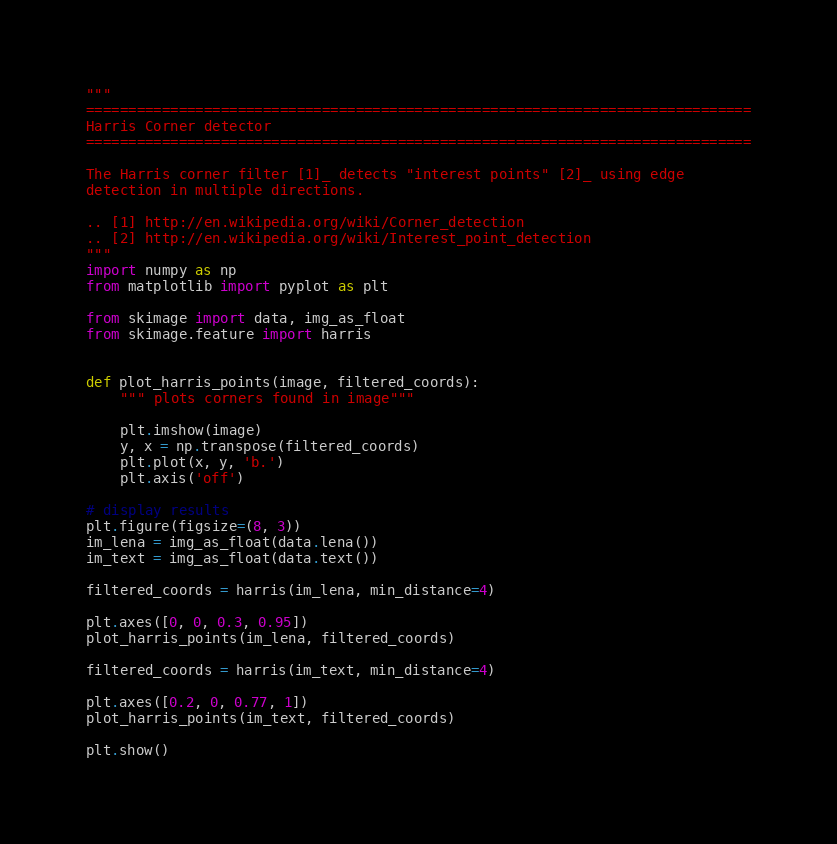Convert code to text. <code><loc_0><loc_0><loc_500><loc_500><_Python_>"""
===============================================================================
Harris Corner detector
===============================================================================

The Harris corner filter [1]_ detects "interest points" [2]_ using edge
detection in multiple directions.

.. [1] http://en.wikipedia.org/wiki/Corner_detection
.. [2] http://en.wikipedia.org/wiki/Interest_point_detection
"""
import numpy as np
from matplotlib import pyplot as plt

from skimage import data, img_as_float
from skimage.feature import harris


def plot_harris_points(image, filtered_coords):
    """ plots corners found in image"""

    plt.imshow(image)
    y, x = np.transpose(filtered_coords)
    plt.plot(x, y, 'b.')
    plt.axis('off')

# display results
plt.figure(figsize=(8, 3))
im_lena = img_as_float(data.lena())
im_text = img_as_float(data.text())

filtered_coords = harris(im_lena, min_distance=4)

plt.axes([0, 0, 0.3, 0.95])
plot_harris_points(im_lena, filtered_coords)

filtered_coords = harris(im_text, min_distance=4)

plt.axes([0.2, 0, 0.77, 1])
plot_harris_points(im_text, filtered_coords)

plt.show()
</code> 